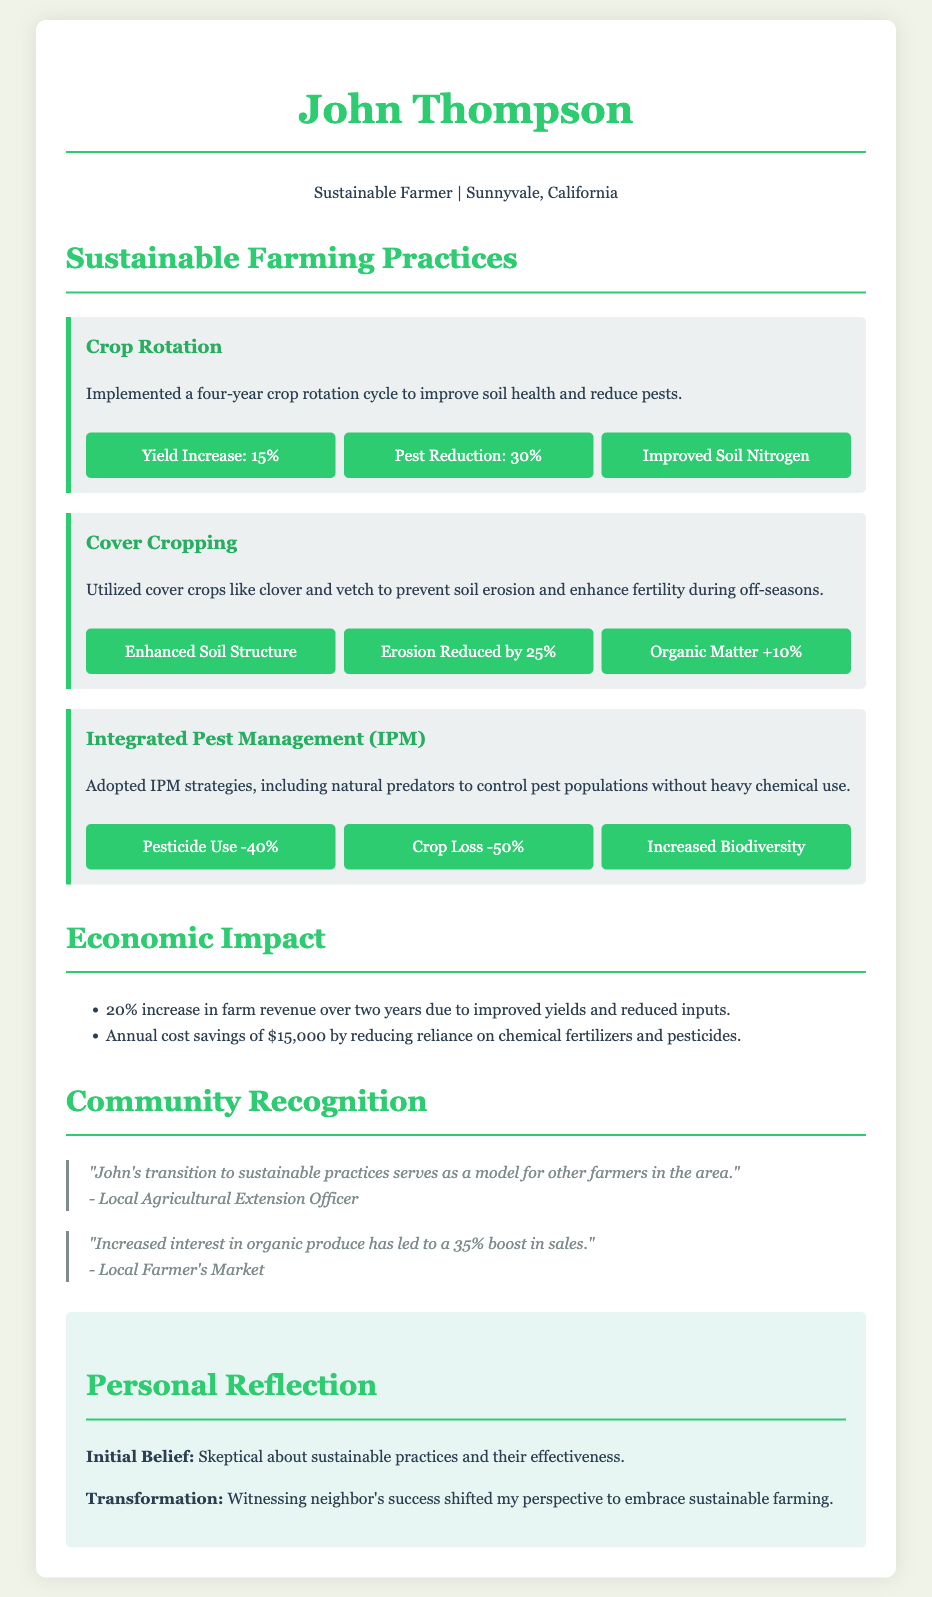What is the name of the farmer? The document states that the farmer's name is John Thompson.
Answer: John Thompson What farming practice led to a 15% yield increase? The document mentions that crop rotation was implemented, which resulted in a 15% yield increase.
Answer: Crop Rotation How much was the annual cost savings from reduced chemical use? The document lists the annual cost savings as $15,000 due to reduced reliance on chemical fertilizers and pesticides.
Answer: $15,000 What was the percentage reduction in pesticide use with IPM? The document states that pesticide use was reduced by 40% after adopting Integrated Pest Management.
Answer: 40% What feedback did the Local Agricultural Extension Officer provide? The feedback highlights John's transition to sustainable practices as a model for other farmers.
Answer: "John's transition to sustainable practices serves as a model for other farmers in the area." What was John Thompson's initial belief about sustainable practices? The reflection part of the document indicates John's initial belief was skepticism about sustainable practices.
Answer: Skeptical What improvement percentage was noted in organic produce sales? The document mentions an increased interest in organic produce leading to a 35% boost in sales.
Answer: 35% What practice helps prevent soil erosion during off-seasons? The use of cover crops is mentioned as a practice to prevent soil erosion during off-seasons.
Answer: Cover Cropping What is the total increase in farm revenue over two years? The document states there was a 20% increase in farm revenue over two years.
Answer: 20% 